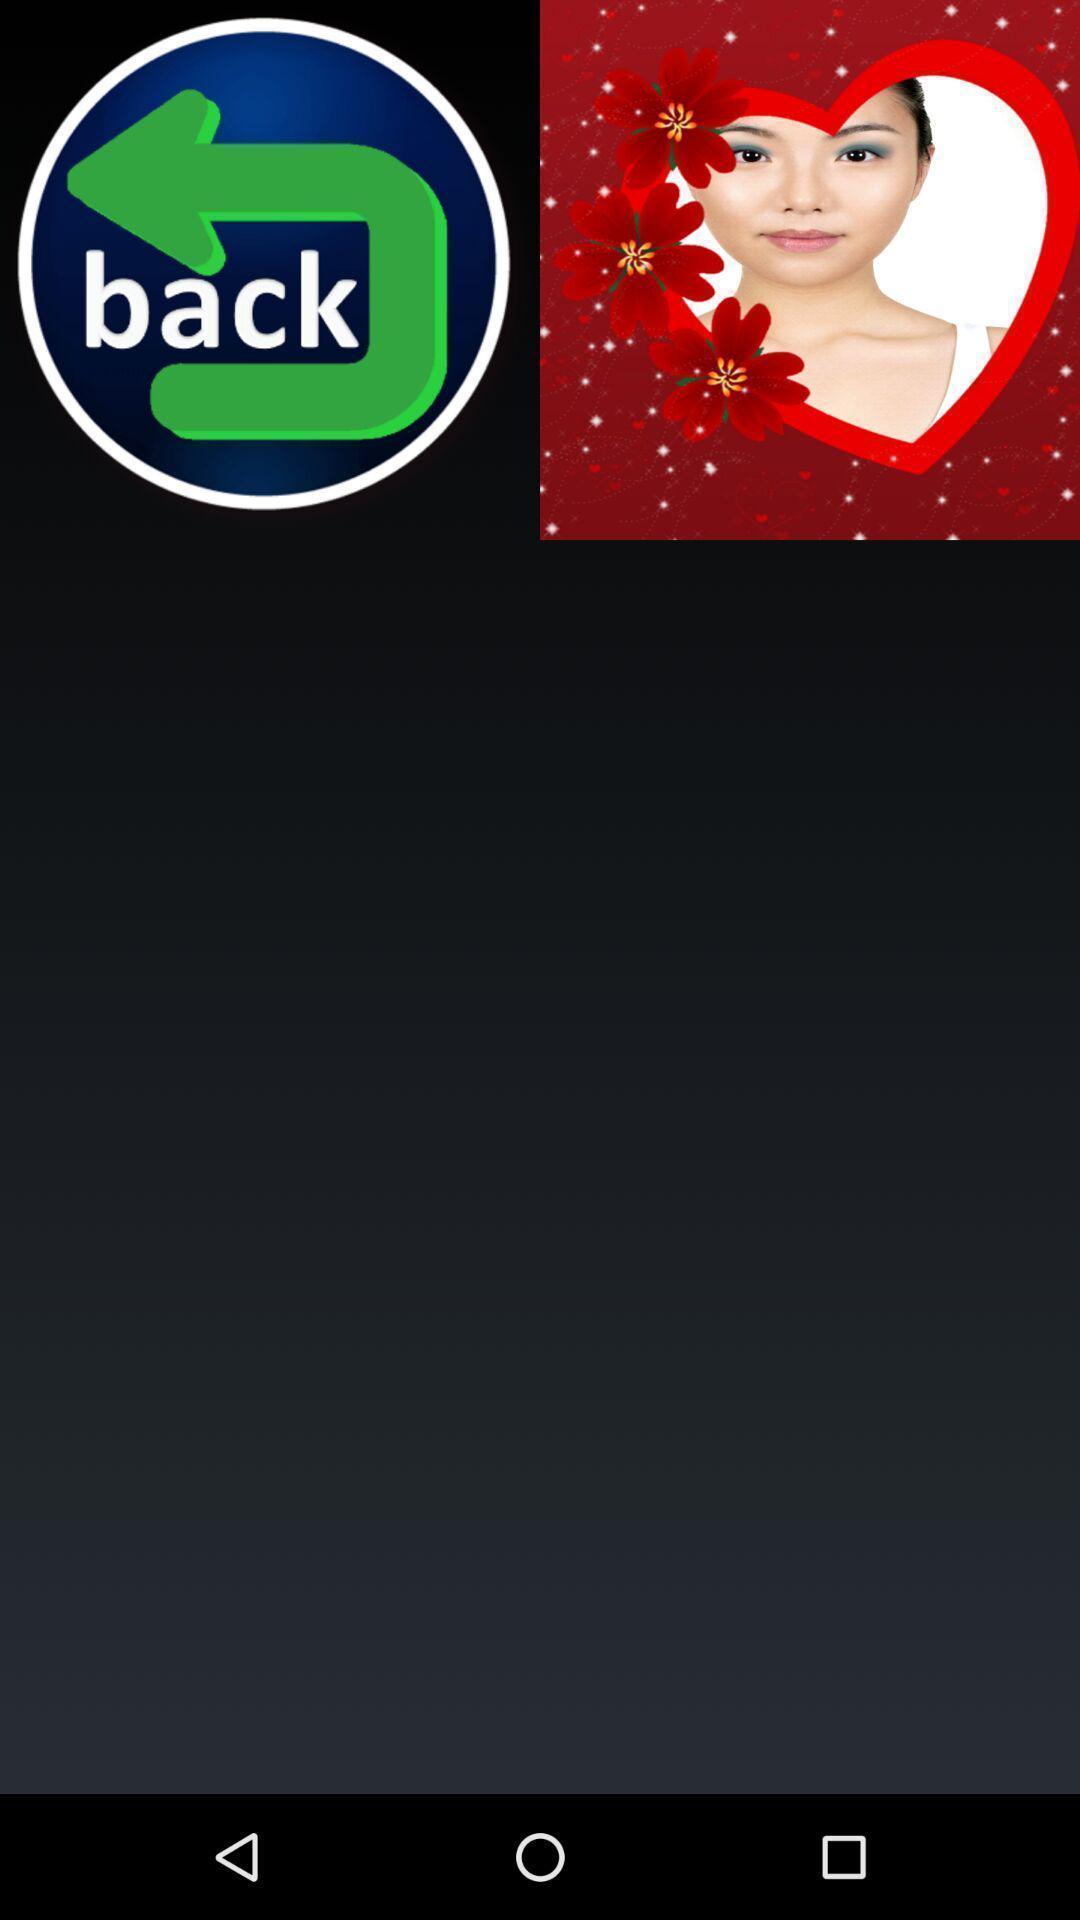What can you discern from this picture? Uploading images in some cards. 